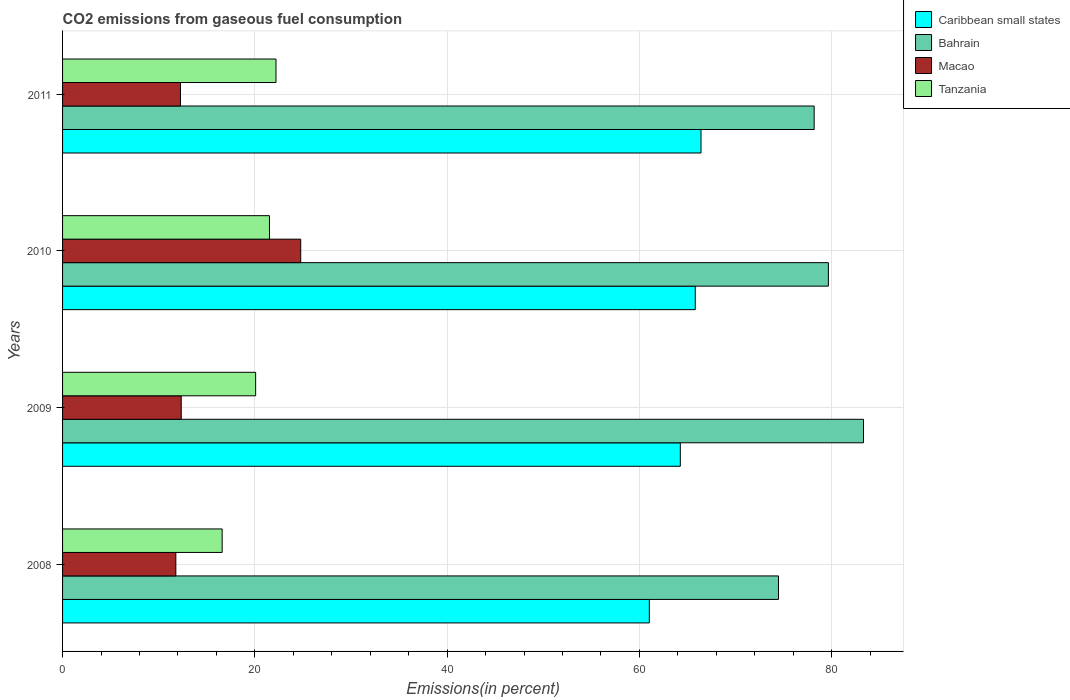Are the number of bars per tick equal to the number of legend labels?
Provide a short and direct response. Yes. How many bars are there on the 4th tick from the top?
Provide a short and direct response. 4. How many bars are there on the 2nd tick from the bottom?
Ensure brevity in your answer.  4. What is the total CO2 emitted in Macao in 2011?
Keep it short and to the point. 12.26. Across all years, what is the maximum total CO2 emitted in Caribbean small states?
Ensure brevity in your answer.  66.41. Across all years, what is the minimum total CO2 emitted in Caribbean small states?
Ensure brevity in your answer.  61.03. In which year was the total CO2 emitted in Bahrain maximum?
Offer a very short reply. 2009. What is the total total CO2 emitted in Bahrain in the graph?
Ensure brevity in your answer.  315.61. What is the difference between the total CO2 emitted in Caribbean small states in 2009 and that in 2010?
Provide a succinct answer. -1.55. What is the difference between the total CO2 emitted in Tanzania in 2011 and the total CO2 emitted in Macao in 2008?
Give a very brief answer. 10.42. What is the average total CO2 emitted in Macao per year?
Your answer should be compact. 15.29. In the year 2008, what is the difference between the total CO2 emitted in Bahrain and total CO2 emitted in Macao?
Your response must be concise. 62.68. What is the ratio of the total CO2 emitted in Tanzania in 2010 to that in 2011?
Ensure brevity in your answer.  0.97. Is the total CO2 emitted in Macao in 2008 less than that in 2011?
Ensure brevity in your answer.  Yes. Is the difference between the total CO2 emitted in Bahrain in 2008 and 2009 greater than the difference between the total CO2 emitted in Macao in 2008 and 2009?
Ensure brevity in your answer.  No. What is the difference between the highest and the second highest total CO2 emitted in Bahrain?
Ensure brevity in your answer.  3.65. What is the difference between the highest and the lowest total CO2 emitted in Macao?
Give a very brief answer. 12.99. In how many years, is the total CO2 emitted in Caribbean small states greater than the average total CO2 emitted in Caribbean small states taken over all years?
Ensure brevity in your answer.  2. What does the 1st bar from the top in 2011 represents?
Your answer should be very brief. Tanzania. What does the 2nd bar from the bottom in 2010 represents?
Offer a terse response. Bahrain. How many bars are there?
Your response must be concise. 16. What is the difference between two consecutive major ticks on the X-axis?
Ensure brevity in your answer.  20. What is the title of the graph?
Keep it short and to the point. CO2 emissions from gaseous fuel consumption. Does "Andorra" appear as one of the legend labels in the graph?
Your response must be concise. No. What is the label or title of the X-axis?
Your answer should be very brief. Emissions(in percent). What is the Emissions(in percent) in Caribbean small states in 2008?
Your answer should be very brief. 61.03. What is the Emissions(in percent) in Bahrain in 2008?
Offer a very short reply. 74.47. What is the Emissions(in percent) in Macao in 2008?
Provide a short and direct response. 11.78. What is the Emissions(in percent) in Tanzania in 2008?
Your answer should be very brief. 16.6. What is the Emissions(in percent) of Caribbean small states in 2009?
Keep it short and to the point. 64.26. What is the Emissions(in percent) in Bahrain in 2009?
Give a very brief answer. 83.31. What is the Emissions(in percent) in Macao in 2009?
Provide a succinct answer. 12.34. What is the Emissions(in percent) in Tanzania in 2009?
Your answer should be very brief. 20.08. What is the Emissions(in percent) in Caribbean small states in 2010?
Offer a very short reply. 65.81. What is the Emissions(in percent) in Bahrain in 2010?
Provide a succinct answer. 79.66. What is the Emissions(in percent) in Macao in 2010?
Keep it short and to the point. 24.77. What is the Emissions(in percent) of Tanzania in 2010?
Your response must be concise. 21.52. What is the Emissions(in percent) of Caribbean small states in 2011?
Offer a very short reply. 66.41. What is the Emissions(in percent) of Bahrain in 2011?
Offer a terse response. 78.18. What is the Emissions(in percent) in Macao in 2011?
Provide a short and direct response. 12.26. What is the Emissions(in percent) in Tanzania in 2011?
Offer a very short reply. 22.2. Across all years, what is the maximum Emissions(in percent) in Caribbean small states?
Give a very brief answer. 66.41. Across all years, what is the maximum Emissions(in percent) of Bahrain?
Make the answer very short. 83.31. Across all years, what is the maximum Emissions(in percent) in Macao?
Make the answer very short. 24.77. Across all years, what is the maximum Emissions(in percent) of Tanzania?
Ensure brevity in your answer.  22.2. Across all years, what is the minimum Emissions(in percent) in Caribbean small states?
Your answer should be very brief. 61.03. Across all years, what is the minimum Emissions(in percent) in Bahrain?
Offer a terse response. 74.47. Across all years, what is the minimum Emissions(in percent) of Macao?
Keep it short and to the point. 11.78. Across all years, what is the minimum Emissions(in percent) of Tanzania?
Your answer should be compact. 16.6. What is the total Emissions(in percent) of Caribbean small states in the graph?
Keep it short and to the point. 257.5. What is the total Emissions(in percent) in Bahrain in the graph?
Your answer should be compact. 315.61. What is the total Emissions(in percent) of Macao in the graph?
Provide a short and direct response. 61.16. What is the total Emissions(in percent) in Tanzania in the graph?
Your answer should be very brief. 80.4. What is the difference between the Emissions(in percent) in Caribbean small states in 2008 and that in 2009?
Offer a very short reply. -3.22. What is the difference between the Emissions(in percent) in Bahrain in 2008 and that in 2009?
Keep it short and to the point. -8.84. What is the difference between the Emissions(in percent) in Macao in 2008 and that in 2009?
Your answer should be very brief. -0.56. What is the difference between the Emissions(in percent) of Tanzania in 2008 and that in 2009?
Keep it short and to the point. -3.48. What is the difference between the Emissions(in percent) in Caribbean small states in 2008 and that in 2010?
Your answer should be compact. -4.78. What is the difference between the Emissions(in percent) of Bahrain in 2008 and that in 2010?
Your answer should be compact. -5.19. What is the difference between the Emissions(in percent) in Macao in 2008 and that in 2010?
Offer a very short reply. -12.99. What is the difference between the Emissions(in percent) in Tanzania in 2008 and that in 2010?
Keep it short and to the point. -4.92. What is the difference between the Emissions(in percent) of Caribbean small states in 2008 and that in 2011?
Your response must be concise. -5.38. What is the difference between the Emissions(in percent) in Bahrain in 2008 and that in 2011?
Provide a succinct answer. -3.71. What is the difference between the Emissions(in percent) of Macao in 2008 and that in 2011?
Provide a short and direct response. -0.48. What is the difference between the Emissions(in percent) in Tanzania in 2008 and that in 2011?
Give a very brief answer. -5.6. What is the difference between the Emissions(in percent) in Caribbean small states in 2009 and that in 2010?
Provide a succinct answer. -1.55. What is the difference between the Emissions(in percent) in Bahrain in 2009 and that in 2010?
Keep it short and to the point. 3.65. What is the difference between the Emissions(in percent) in Macao in 2009 and that in 2010?
Provide a short and direct response. -12.43. What is the difference between the Emissions(in percent) in Tanzania in 2009 and that in 2010?
Give a very brief answer. -1.44. What is the difference between the Emissions(in percent) in Caribbean small states in 2009 and that in 2011?
Your response must be concise. -2.15. What is the difference between the Emissions(in percent) in Bahrain in 2009 and that in 2011?
Provide a short and direct response. 5.13. What is the difference between the Emissions(in percent) in Macao in 2009 and that in 2011?
Give a very brief answer. 0.08. What is the difference between the Emissions(in percent) in Tanzania in 2009 and that in 2011?
Keep it short and to the point. -2.12. What is the difference between the Emissions(in percent) of Caribbean small states in 2010 and that in 2011?
Provide a short and direct response. -0.6. What is the difference between the Emissions(in percent) in Bahrain in 2010 and that in 2011?
Provide a succinct answer. 1.48. What is the difference between the Emissions(in percent) of Macao in 2010 and that in 2011?
Your answer should be compact. 12.51. What is the difference between the Emissions(in percent) of Tanzania in 2010 and that in 2011?
Provide a succinct answer. -0.68. What is the difference between the Emissions(in percent) of Caribbean small states in 2008 and the Emissions(in percent) of Bahrain in 2009?
Provide a short and direct response. -22.28. What is the difference between the Emissions(in percent) in Caribbean small states in 2008 and the Emissions(in percent) in Macao in 2009?
Your answer should be very brief. 48.69. What is the difference between the Emissions(in percent) of Caribbean small states in 2008 and the Emissions(in percent) of Tanzania in 2009?
Make the answer very short. 40.95. What is the difference between the Emissions(in percent) of Bahrain in 2008 and the Emissions(in percent) of Macao in 2009?
Offer a terse response. 62.12. What is the difference between the Emissions(in percent) in Bahrain in 2008 and the Emissions(in percent) in Tanzania in 2009?
Provide a short and direct response. 54.38. What is the difference between the Emissions(in percent) of Macao in 2008 and the Emissions(in percent) of Tanzania in 2009?
Ensure brevity in your answer.  -8.3. What is the difference between the Emissions(in percent) of Caribbean small states in 2008 and the Emissions(in percent) of Bahrain in 2010?
Keep it short and to the point. -18.62. What is the difference between the Emissions(in percent) of Caribbean small states in 2008 and the Emissions(in percent) of Macao in 2010?
Offer a very short reply. 36.26. What is the difference between the Emissions(in percent) of Caribbean small states in 2008 and the Emissions(in percent) of Tanzania in 2010?
Ensure brevity in your answer.  39.51. What is the difference between the Emissions(in percent) of Bahrain in 2008 and the Emissions(in percent) of Macao in 2010?
Provide a short and direct response. 49.69. What is the difference between the Emissions(in percent) in Bahrain in 2008 and the Emissions(in percent) in Tanzania in 2010?
Provide a succinct answer. 52.95. What is the difference between the Emissions(in percent) of Macao in 2008 and the Emissions(in percent) of Tanzania in 2010?
Ensure brevity in your answer.  -9.74. What is the difference between the Emissions(in percent) of Caribbean small states in 2008 and the Emissions(in percent) of Bahrain in 2011?
Your response must be concise. -17.14. What is the difference between the Emissions(in percent) of Caribbean small states in 2008 and the Emissions(in percent) of Macao in 2011?
Your answer should be very brief. 48.77. What is the difference between the Emissions(in percent) in Caribbean small states in 2008 and the Emissions(in percent) in Tanzania in 2011?
Give a very brief answer. 38.83. What is the difference between the Emissions(in percent) of Bahrain in 2008 and the Emissions(in percent) of Macao in 2011?
Provide a succinct answer. 62.2. What is the difference between the Emissions(in percent) in Bahrain in 2008 and the Emissions(in percent) in Tanzania in 2011?
Provide a short and direct response. 52.27. What is the difference between the Emissions(in percent) in Macao in 2008 and the Emissions(in percent) in Tanzania in 2011?
Ensure brevity in your answer.  -10.42. What is the difference between the Emissions(in percent) in Caribbean small states in 2009 and the Emissions(in percent) in Bahrain in 2010?
Your answer should be compact. -15.4. What is the difference between the Emissions(in percent) in Caribbean small states in 2009 and the Emissions(in percent) in Macao in 2010?
Provide a short and direct response. 39.49. What is the difference between the Emissions(in percent) in Caribbean small states in 2009 and the Emissions(in percent) in Tanzania in 2010?
Ensure brevity in your answer.  42.74. What is the difference between the Emissions(in percent) in Bahrain in 2009 and the Emissions(in percent) in Macao in 2010?
Provide a succinct answer. 58.54. What is the difference between the Emissions(in percent) of Bahrain in 2009 and the Emissions(in percent) of Tanzania in 2010?
Offer a terse response. 61.79. What is the difference between the Emissions(in percent) of Macao in 2009 and the Emissions(in percent) of Tanzania in 2010?
Offer a terse response. -9.18. What is the difference between the Emissions(in percent) of Caribbean small states in 2009 and the Emissions(in percent) of Bahrain in 2011?
Give a very brief answer. -13.92. What is the difference between the Emissions(in percent) of Caribbean small states in 2009 and the Emissions(in percent) of Macao in 2011?
Offer a very short reply. 51.99. What is the difference between the Emissions(in percent) of Caribbean small states in 2009 and the Emissions(in percent) of Tanzania in 2011?
Provide a short and direct response. 42.06. What is the difference between the Emissions(in percent) of Bahrain in 2009 and the Emissions(in percent) of Macao in 2011?
Make the answer very short. 71.04. What is the difference between the Emissions(in percent) of Bahrain in 2009 and the Emissions(in percent) of Tanzania in 2011?
Offer a very short reply. 61.11. What is the difference between the Emissions(in percent) in Macao in 2009 and the Emissions(in percent) in Tanzania in 2011?
Ensure brevity in your answer.  -9.86. What is the difference between the Emissions(in percent) in Caribbean small states in 2010 and the Emissions(in percent) in Bahrain in 2011?
Offer a very short reply. -12.37. What is the difference between the Emissions(in percent) of Caribbean small states in 2010 and the Emissions(in percent) of Macao in 2011?
Provide a short and direct response. 53.55. What is the difference between the Emissions(in percent) of Caribbean small states in 2010 and the Emissions(in percent) of Tanzania in 2011?
Give a very brief answer. 43.61. What is the difference between the Emissions(in percent) of Bahrain in 2010 and the Emissions(in percent) of Macao in 2011?
Your answer should be compact. 67.39. What is the difference between the Emissions(in percent) in Bahrain in 2010 and the Emissions(in percent) in Tanzania in 2011?
Offer a terse response. 57.46. What is the difference between the Emissions(in percent) in Macao in 2010 and the Emissions(in percent) in Tanzania in 2011?
Keep it short and to the point. 2.57. What is the average Emissions(in percent) of Caribbean small states per year?
Offer a very short reply. 64.38. What is the average Emissions(in percent) of Bahrain per year?
Make the answer very short. 78.9. What is the average Emissions(in percent) of Macao per year?
Provide a succinct answer. 15.29. What is the average Emissions(in percent) of Tanzania per year?
Your answer should be compact. 20.1. In the year 2008, what is the difference between the Emissions(in percent) in Caribbean small states and Emissions(in percent) in Bahrain?
Your answer should be compact. -13.43. In the year 2008, what is the difference between the Emissions(in percent) of Caribbean small states and Emissions(in percent) of Macao?
Provide a succinct answer. 49.25. In the year 2008, what is the difference between the Emissions(in percent) in Caribbean small states and Emissions(in percent) in Tanzania?
Your answer should be very brief. 44.43. In the year 2008, what is the difference between the Emissions(in percent) of Bahrain and Emissions(in percent) of Macao?
Your answer should be very brief. 62.68. In the year 2008, what is the difference between the Emissions(in percent) in Bahrain and Emissions(in percent) in Tanzania?
Offer a terse response. 57.87. In the year 2008, what is the difference between the Emissions(in percent) of Macao and Emissions(in percent) of Tanzania?
Your answer should be compact. -4.82. In the year 2009, what is the difference between the Emissions(in percent) in Caribbean small states and Emissions(in percent) in Bahrain?
Provide a succinct answer. -19.05. In the year 2009, what is the difference between the Emissions(in percent) in Caribbean small states and Emissions(in percent) in Macao?
Keep it short and to the point. 51.91. In the year 2009, what is the difference between the Emissions(in percent) in Caribbean small states and Emissions(in percent) in Tanzania?
Provide a short and direct response. 44.17. In the year 2009, what is the difference between the Emissions(in percent) of Bahrain and Emissions(in percent) of Macao?
Make the answer very short. 70.97. In the year 2009, what is the difference between the Emissions(in percent) of Bahrain and Emissions(in percent) of Tanzania?
Make the answer very short. 63.23. In the year 2009, what is the difference between the Emissions(in percent) of Macao and Emissions(in percent) of Tanzania?
Your answer should be compact. -7.74. In the year 2010, what is the difference between the Emissions(in percent) of Caribbean small states and Emissions(in percent) of Bahrain?
Offer a very short reply. -13.85. In the year 2010, what is the difference between the Emissions(in percent) of Caribbean small states and Emissions(in percent) of Macao?
Give a very brief answer. 41.04. In the year 2010, what is the difference between the Emissions(in percent) of Caribbean small states and Emissions(in percent) of Tanzania?
Provide a succinct answer. 44.29. In the year 2010, what is the difference between the Emissions(in percent) of Bahrain and Emissions(in percent) of Macao?
Ensure brevity in your answer.  54.89. In the year 2010, what is the difference between the Emissions(in percent) in Bahrain and Emissions(in percent) in Tanzania?
Provide a succinct answer. 58.14. In the year 2010, what is the difference between the Emissions(in percent) of Macao and Emissions(in percent) of Tanzania?
Provide a short and direct response. 3.25. In the year 2011, what is the difference between the Emissions(in percent) in Caribbean small states and Emissions(in percent) in Bahrain?
Give a very brief answer. -11.77. In the year 2011, what is the difference between the Emissions(in percent) of Caribbean small states and Emissions(in percent) of Macao?
Make the answer very short. 54.14. In the year 2011, what is the difference between the Emissions(in percent) in Caribbean small states and Emissions(in percent) in Tanzania?
Offer a terse response. 44.21. In the year 2011, what is the difference between the Emissions(in percent) in Bahrain and Emissions(in percent) in Macao?
Your answer should be very brief. 65.91. In the year 2011, what is the difference between the Emissions(in percent) in Bahrain and Emissions(in percent) in Tanzania?
Provide a succinct answer. 55.98. In the year 2011, what is the difference between the Emissions(in percent) of Macao and Emissions(in percent) of Tanzania?
Your answer should be very brief. -9.94. What is the ratio of the Emissions(in percent) of Caribbean small states in 2008 to that in 2009?
Give a very brief answer. 0.95. What is the ratio of the Emissions(in percent) of Bahrain in 2008 to that in 2009?
Provide a short and direct response. 0.89. What is the ratio of the Emissions(in percent) of Macao in 2008 to that in 2009?
Offer a terse response. 0.95. What is the ratio of the Emissions(in percent) of Tanzania in 2008 to that in 2009?
Make the answer very short. 0.83. What is the ratio of the Emissions(in percent) in Caribbean small states in 2008 to that in 2010?
Offer a terse response. 0.93. What is the ratio of the Emissions(in percent) in Bahrain in 2008 to that in 2010?
Ensure brevity in your answer.  0.93. What is the ratio of the Emissions(in percent) of Macao in 2008 to that in 2010?
Your answer should be compact. 0.48. What is the ratio of the Emissions(in percent) of Tanzania in 2008 to that in 2010?
Your answer should be very brief. 0.77. What is the ratio of the Emissions(in percent) in Caribbean small states in 2008 to that in 2011?
Your answer should be very brief. 0.92. What is the ratio of the Emissions(in percent) of Bahrain in 2008 to that in 2011?
Provide a short and direct response. 0.95. What is the ratio of the Emissions(in percent) of Macao in 2008 to that in 2011?
Ensure brevity in your answer.  0.96. What is the ratio of the Emissions(in percent) of Tanzania in 2008 to that in 2011?
Make the answer very short. 0.75. What is the ratio of the Emissions(in percent) of Caribbean small states in 2009 to that in 2010?
Provide a succinct answer. 0.98. What is the ratio of the Emissions(in percent) of Bahrain in 2009 to that in 2010?
Provide a short and direct response. 1.05. What is the ratio of the Emissions(in percent) of Macao in 2009 to that in 2010?
Give a very brief answer. 0.5. What is the ratio of the Emissions(in percent) in Tanzania in 2009 to that in 2010?
Offer a terse response. 0.93. What is the ratio of the Emissions(in percent) of Caribbean small states in 2009 to that in 2011?
Your answer should be very brief. 0.97. What is the ratio of the Emissions(in percent) of Bahrain in 2009 to that in 2011?
Give a very brief answer. 1.07. What is the ratio of the Emissions(in percent) in Macao in 2009 to that in 2011?
Your answer should be compact. 1.01. What is the ratio of the Emissions(in percent) of Tanzania in 2009 to that in 2011?
Ensure brevity in your answer.  0.9. What is the ratio of the Emissions(in percent) of Bahrain in 2010 to that in 2011?
Give a very brief answer. 1.02. What is the ratio of the Emissions(in percent) in Macao in 2010 to that in 2011?
Provide a succinct answer. 2.02. What is the ratio of the Emissions(in percent) of Tanzania in 2010 to that in 2011?
Keep it short and to the point. 0.97. What is the difference between the highest and the second highest Emissions(in percent) in Caribbean small states?
Your answer should be very brief. 0.6. What is the difference between the highest and the second highest Emissions(in percent) of Bahrain?
Offer a terse response. 3.65. What is the difference between the highest and the second highest Emissions(in percent) in Macao?
Your answer should be very brief. 12.43. What is the difference between the highest and the second highest Emissions(in percent) of Tanzania?
Your response must be concise. 0.68. What is the difference between the highest and the lowest Emissions(in percent) of Caribbean small states?
Give a very brief answer. 5.38. What is the difference between the highest and the lowest Emissions(in percent) in Bahrain?
Make the answer very short. 8.84. What is the difference between the highest and the lowest Emissions(in percent) of Macao?
Ensure brevity in your answer.  12.99. What is the difference between the highest and the lowest Emissions(in percent) of Tanzania?
Your answer should be very brief. 5.6. 